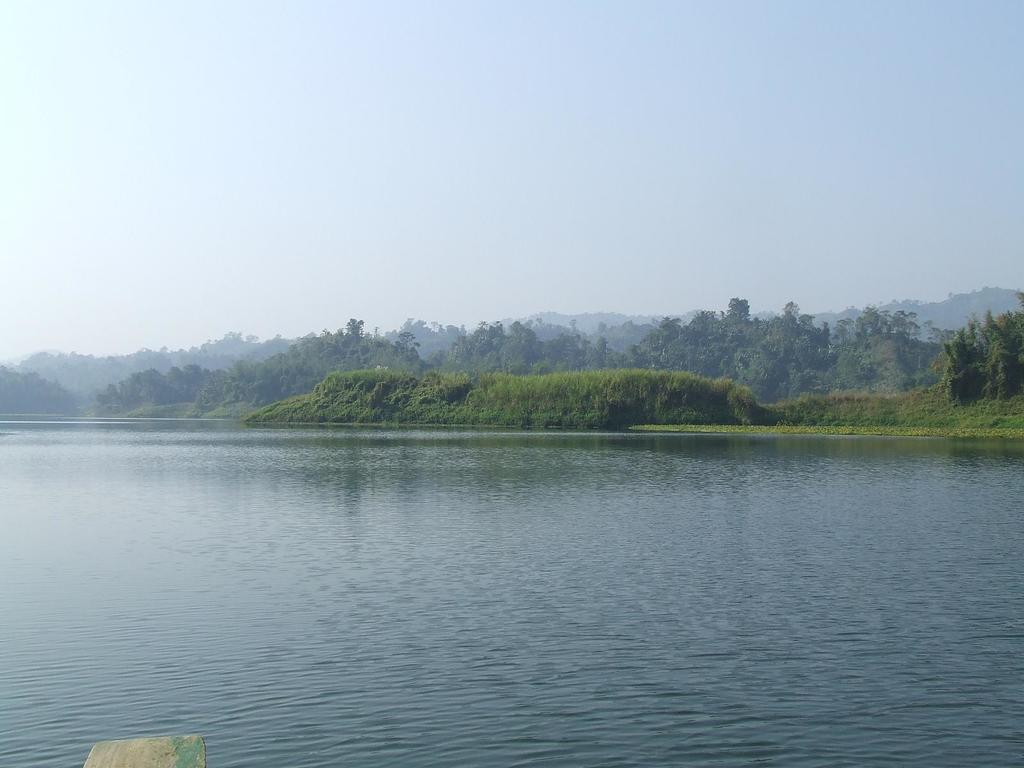What is present at the bottom of the image? There is water at the bottom side of the image. What can be seen in the center of the image? There are trees in the center of the image. What type of playground equipment can be seen in the image? There is no playground equipment present in the image; it features water and trees. How many birds are perched on the trees in the image? There are no birds visible in the image. 